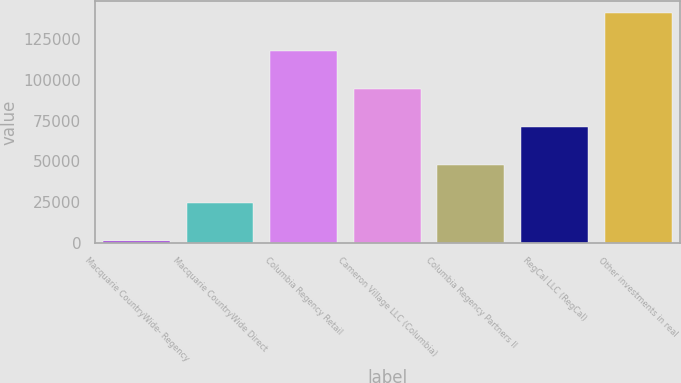Convert chart. <chart><loc_0><loc_0><loc_500><loc_500><bar_chart><fcel>Macquarie CountryWide- Regency<fcel>Macquarie CountryWide Direct<fcel>Columbia Regency Retail<fcel>Cameron Village LLC (Columbia)<fcel>Columbia Regency Partners II<fcel>RegCal LLC (RegCal)<fcel>Other investments in real<nl><fcel>1140<fcel>24463.8<fcel>117759<fcel>94435.2<fcel>47787.6<fcel>71111.4<fcel>141083<nl></chart> 